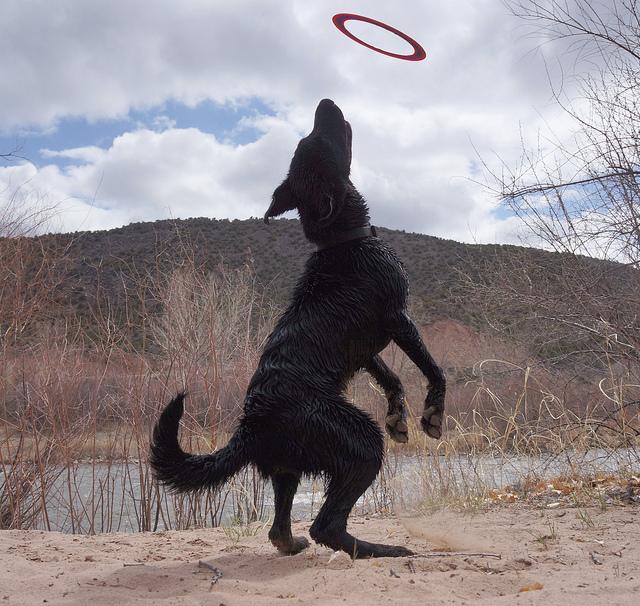What type of animal is this?
Short answer required. Dog. Is the dog wet or dry?
Quick response, please. Wet. Where is the body of water?
Answer briefly. Behind dog. What is the dog about to catch?
Be succinct. Frisbee. 